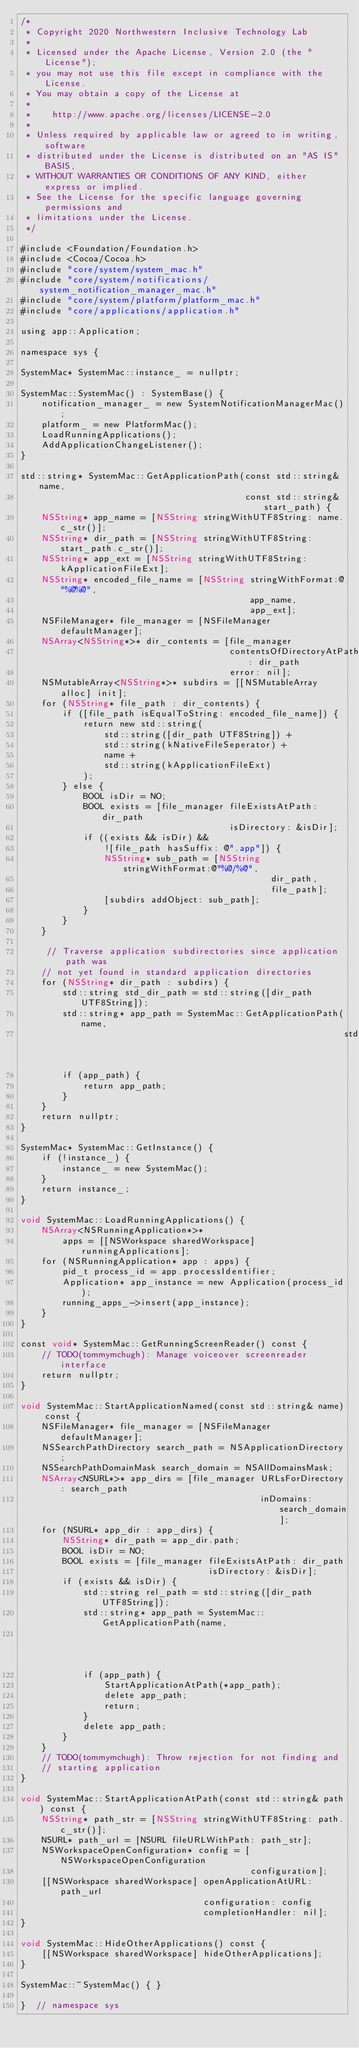<code> <loc_0><loc_0><loc_500><loc_500><_ObjectiveC_>/*
 * Copyright 2020 Northwestern Inclusive Technology Lab
 *
 * Licensed under the Apache License, Version 2.0 (the "License");
 * you may not use this file except in compliance with the License.
 * You may obtain a copy of the License at
 *
 *    http://www.apache.org/licenses/LICENSE-2.0
 *
 * Unless required by applicable law or agreed to in writing, software
 * distributed under the License is distributed on an "AS IS" BASIS,
 * WITHOUT WARRANTIES OR CONDITIONS OF ANY KIND, either express or implied.
 * See the License for the specific language governing permissions and
 * limitations under the License.
 */

#include <Foundation/Foundation.h>
#include <Cocoa/Cocoa.h>
#include "core/system/system_mac.h"
#include "core/system/notifications/system_notification_manager_mac.h"
#include "core/system/platform/platform_mac.h"
#include "core/applications/application.h"

using app::Application;

namespace sys {

SystemMac* SystemMac::instance_ = nullptr;

SystemMac::SystemMac() : SystemBase() {
    notification_manager_ = new SystemNotificationManagerMac();
    platform_ = new PlatformMac();
    LoadRunningApplications();
    AddApplicationChangeListener();
}

std::string* SystemMac::GetApplicationPath(const std::string& name,
                                           const std::string& start_path) {
    NSString* app_name = [NSString stringWithUTF8String: name.c_str()];
    NSString* dir_path = [NSString stringWithUTF8String: start_path.c_str()];
    NSString* app_ext = [NSString stringWithUTF8String: kApplicationFileExt];
    NSString* encoded_file_name = [NSString stringWithFormat:@"%@%@",
                                            app_name,
                                            app_ext];
    NSFileManager* file_manager = [NSFileManager defaultManager];
    NSArray<NSString*>* dir_contents = [file_manager
                                        contentsOfDirectoryAtPath: dir_path
                                        error: nil];
    NSMutableArray<NSString*>* subdirs = [[NSMutableArray alloc] init];
    for (NSString* file_path : dir_contents) {
        if ([file_path isEqualToString: encoded_file_name]) {
            return new std::string(
                std::string([dir_path UTF8String]) +
                std::string(kNativeFileSeperator) +
                name +
                std::string(kApplicationFileExt)
            );
        } else {
            BOOL isDir = NO;
            BOOL exists = [file_manager fileExistsAtPath: dir_path
                                        isDirectory: &isDir];
            if ((exists && isDir) &&
                ![file_path hasSuffix: @".app"]) {
                NSString* sub_path = [NSString stringWithFormat:@"%@/%@",
                                                dir_path,
                                                file_path];
                [subdirs addObject: sub_path];
            }
        }
    }

     // Traverse application subdirectories since application path was
    // not yet found in standard application directories
    for (NSString* dir_path : subdirs) {
        std::string std_dir_path = std::string([dir_path UTF8String]);
        std::string* app_path = SystemMac::GetApplicationPath(name,
                                                              std_dir_path);
        if (app_path) {
            return app_path; 
        }
    }
    return nullptr;
}

SystemMac* SystemMac::GetInstance() {
    if (!instance_) {
        instance_ = new SystemMac();
    }
    return instance_;
}

void SystemMac::LoadRunningApplications() {
    NSArray<NSRunningApplication*>*
        apps = [[NSWorkspace sharedWorkspace] runningApplications];
    for (NSRunningApplication* app : apps) {
        pid_t process_id = app.processIdentifier;
        Application* app_instance = new Application(process_id);
        running_apps_->insert(app_instance);
    }
}

const void* SystemMac::GetRunningScreenReader() const {
    // TODO(tommymchugh): Manage voiceover screenreader interface
    return nullptr;
}

void SystemMac::StartApplicationNamed(const std::string& name) const {
    NSFileManager* file_manager = [NSFileManager defaultManager];
    NSSearchPathDirectory search_path = NSApplicationDirectory;
    NSSearchPathDomainMask search_domain = NSAllDomainsMask;
    NSArray<NSURL*>* app_dirs = [file_manager URLsForDirectory: search_path
                                              inDomains: search_domain];
    for (NSURL* app_dir : app_dirs) {
        NSString* dir_path = app_dir.path;
        BOOL isDir = NO;
        BOOL exists = [file_manager fileExistsAtPath: dir_path
                                    isDirectory: &isDir];
        if (exists && isDir) {
            std::string rel_path = std::string([dir_path UTF8String]);
            std::string* app_path = SystemMac::GetApplicationPath(name,
                                                                  rel_path);
            if (app_path) {
                StartApplicationAtPath(*app_path);
                delete app_path;
                return;
            }
            delete app_path;
        }
    }
    // TODO(tommymchugh): Throw rejection for not finding and
    // starting application
}

void SystemMac::StartApplicationAtPath(const std::string& path) const {
    NSString* path_str = [NSString stringWithUTF8String: path.c_str()];
    NSURL* path_url = [NSURL fileURLWithPath: path_str];
    NSWorkspaceOpenConfiguration* config = [NSWorkspaceOpenConfiguration
                                            configuration];
    [[NSWorkspace sharedWorkspace] openApplicationAtURL: path_url
                                   configuration: config
                                   completionHandler: nil];
}

void SystemMac::HideOtherApplications() const {
    [[NSWorkspace sharedWorkspace] hideOtherApplications];
}

SystemMac::~SystemMac() { }

}  // namespace sys
</code> 